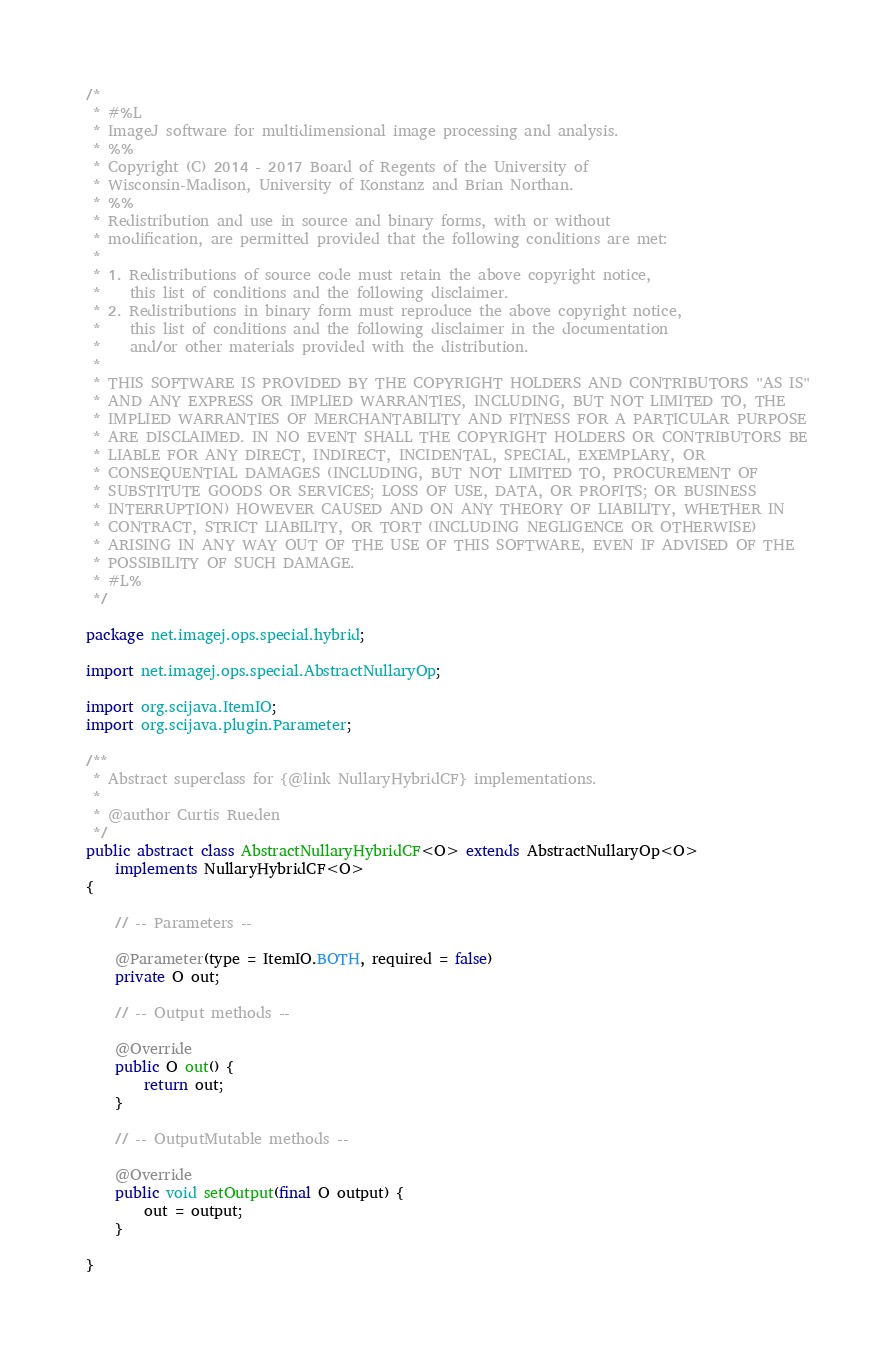<code> <loc_0><loc_0><loc_500><loc_500><_Java_>/*
 * #%L
 * ImageJ software for multidimensional image processing and analysis.
 * %%
 * Copyright (C) 2014 - 2017 Board of Regents of the University of
 * Wisconsin-Madison, University of Konstanz and Brian Northan.
 * %%
 * Redistribution and use in source and binary forms, with or without
 * modification, are permitted provided that the following conditions are met:
 * 
 * 1. Redistributions of source code must retain the above copyright notice,
 *    this list of conditions and the following disclaimer.
 * 2. Redistributions in binary form must reproduce the above copyright notice,
 *    this list of conditions and the following disclaimer in the documentation
 *    and/or other materials provided with the distribution.
 * 
 * THIS SOFTWARE IS PROVIDED BY THE COPYRIGHT HOLDERS AND CONTRIBUTORS "AS IS"
 * AND ANY EXPRESS OR IMPLIED WARRANTIES, INCLUDING, BUT NOT LIMITED TO, THE
 * IMPLIED WARRANTIES OF MERCHANTABILITY AND FITNESS FOR A PARTICULAR PURPOSE
 * ARE DISCLAIMED. IN NO EVENT SHALL THE COPYRIGHT HOLDERS OR CONTRIBUTORS BE
 * LIABLE FOR ANY DIRECT, INDIRECT, INCIDENTAL, SPECIAL, EXEMPLARY, OR
 * CONSEQUENTIAL DAMAGES (INCLUDING, BUT NOT LIMITED TO, PROCUREMENT OF
 * SUBSTITUTE GOODS OR SERVICES; LOSS OF USE, DATA, OR PROFITS; OR BUSINESS
 * INTERRUPTION) HOWEVER CAUSED AND ON ANY THEORY OF LIABILITY, WHETHER IN
 * CONTRACT, STRICT LIABILITY, OR TORT (INCLUDING NEGLIGENCE OR OTHERWISE)
 * ARISING IN ANY WAY OUT OF THE USE OF THIS SOFTWARE, EVEN IF ADVISED OF THE
 * POSSIBILITY OF SUCH DAMAGE.
 * #L%
 */

package net.imagej.ops.special.hybrid;

import net.imagej.ops.special.AbstractNullaryOp;

import org.scijava.ItemIO;
import org.scijava.plugin.Parameter;

/**
 * Abstract superclass for {@link NullaryHybridCF} implementations.
 * 
 * @author Curtis Rueden
 */
public abstract class AbstractNullaryHybridCF<O> extends AbstractNullaryOp<O>
	implements NullaryHybridCF<O>
{

	// -- Parameters --

	@Parameter(type = ItemIO.BOTH, required = false)
	private O out;

	// -- Output methods --

	@Override
	public O out() {
		return out;
	}

	// -- OutputMutable methods --

	@Override
	public void setOutput(final O output) {
		out = output;
	}

}
</code> 